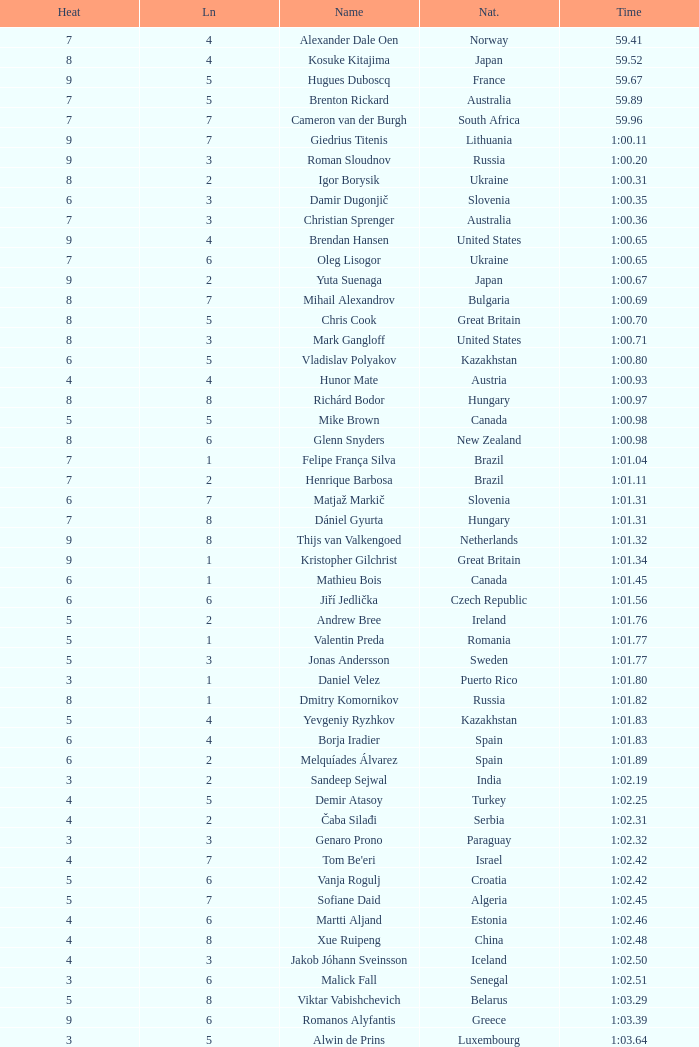What is the time in a heat smaller than 5, in Lane 5, for Vietnam? 1:06.36. 